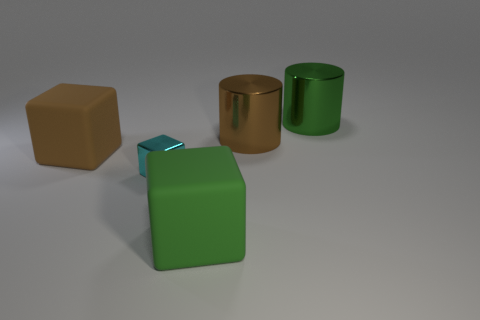Add 4 big green rubber things. How many objects exist? 9 Subtract all cylinders. How many objects are left? 3 Subtract all small cyan metal cubes. Subtract all brown rubber cubes. How many objects are left? 3 Add 4 brown metal things. How many brown metal things are left? 5 Add 4 green cylinders. How many green cylinders exist? 5 Subtract 0 red balls. How many objects are left? 5 